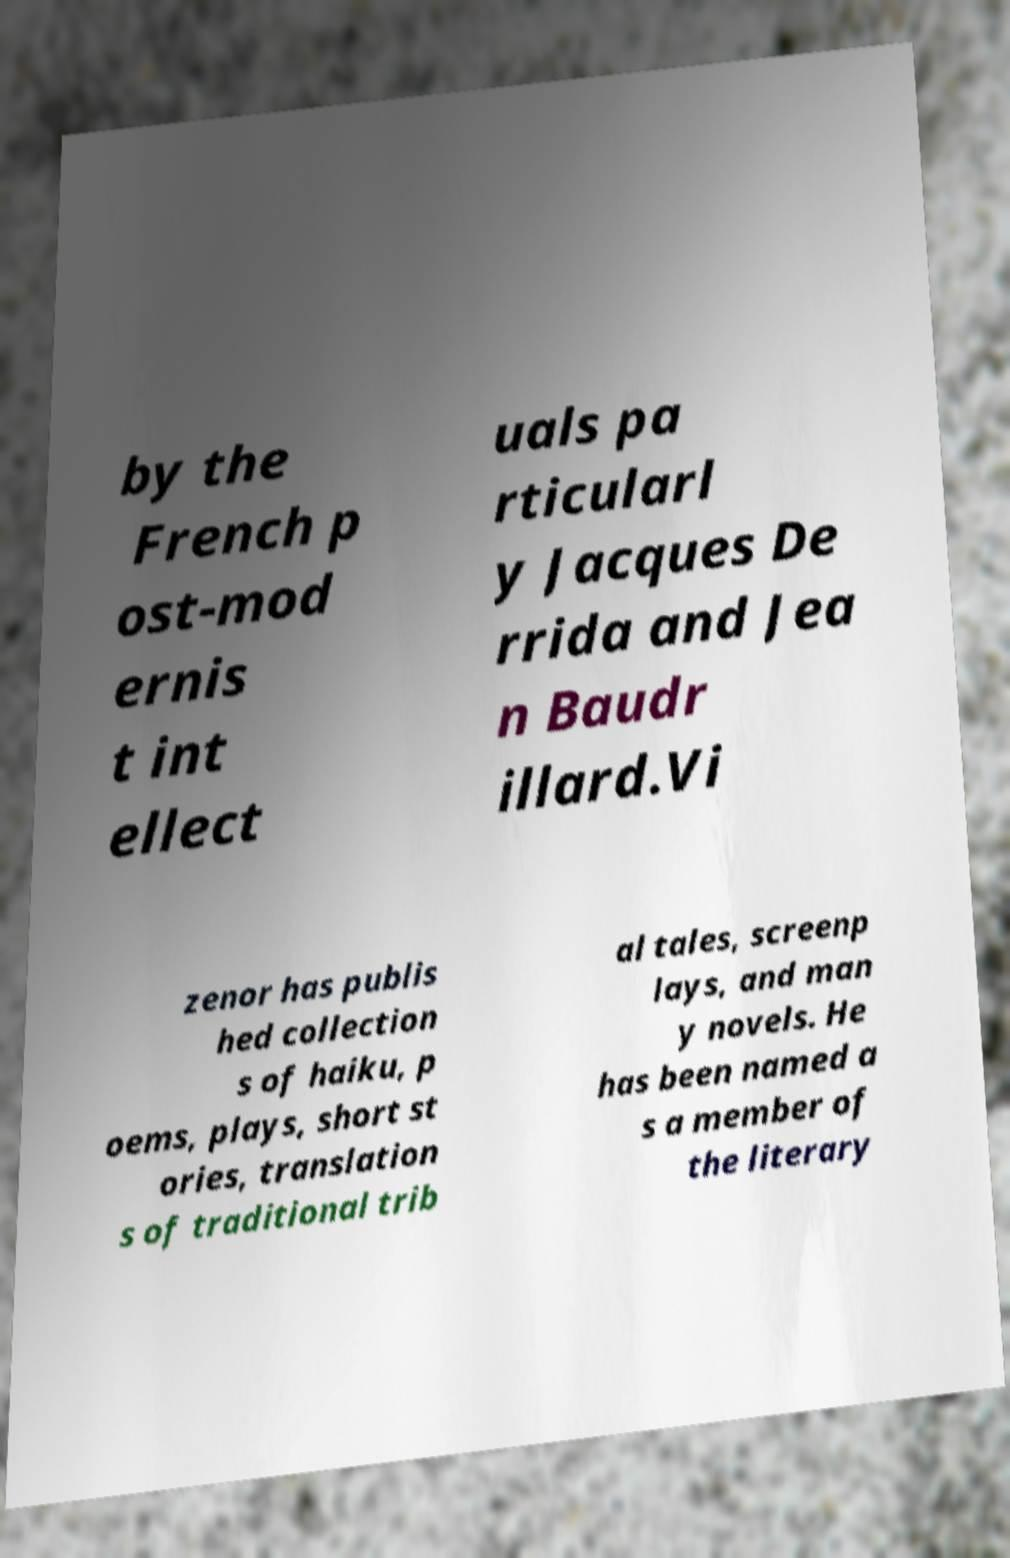For documentation purposes, I need the text within this image transcribed. Could you provide that? by the French p ost-mod ernis t int ellect uals pa rticularl y Jacques De rrida and Jea n Baudr illard.Vi zenor has publis hed collection s of haiku, p oems, plays, short st ories, translation s of traditional trib al tales, screenp lays, and man y novels. He has been named a s a member of the literary 